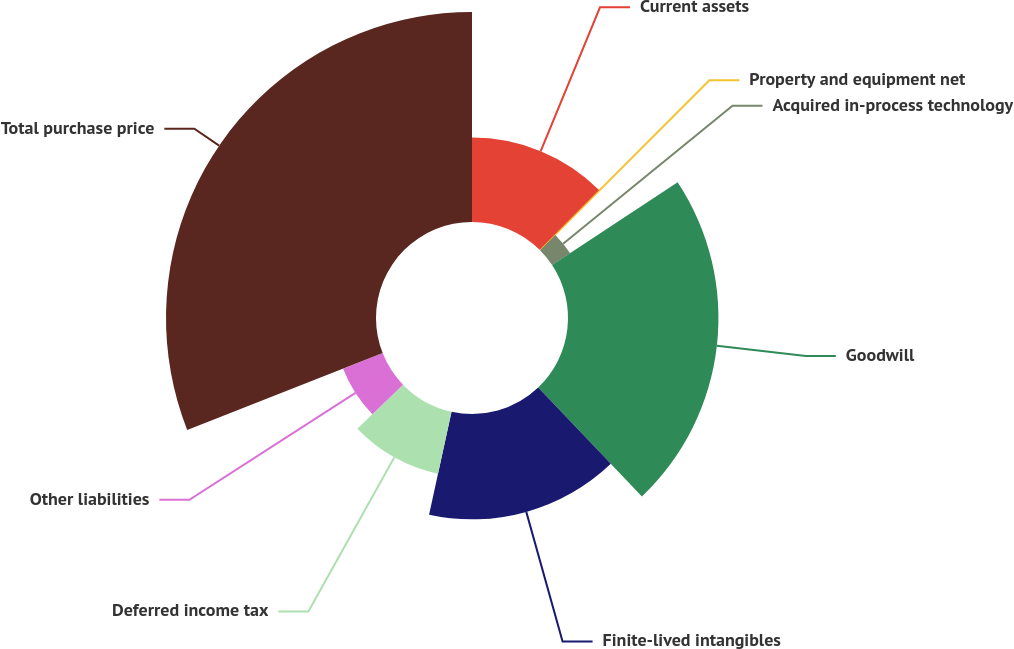<chart> <loc_0><loc_0><loc_500><loc_500><pie_chart><fcel>Current assets<fcel>Property and equipment net<fcel>Acquired in-process technology<fcel>Goodwill<fcel>Finite-lived intangibles<fcel>Deferred income tax<fcel>Other liabilities<fcel>Total purchase price<nl><fcel>12.44%<fcel>0.09%<fcel>3.18%<fcel>22.18%<fcel>15.53%<fcel>9.35%<fcel>6.27%<fcel>30.96%<nl></chart> 